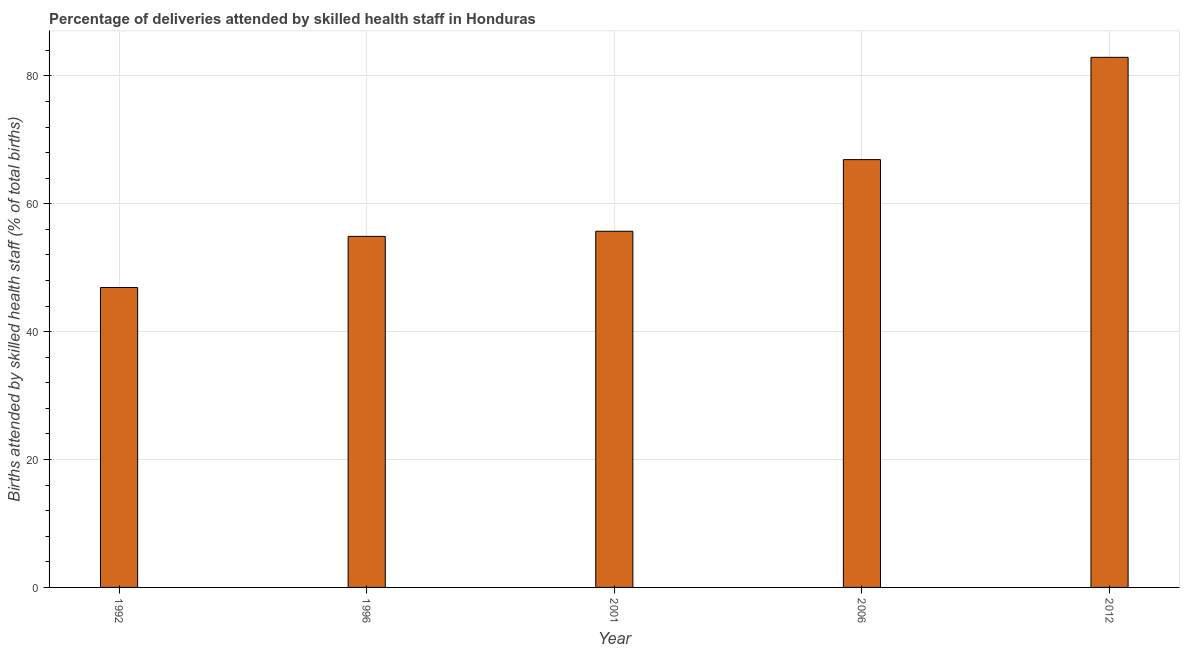What is the title of the graph?
Ensure brevity in your answer.  Percentage of deliveries attended by skilled health staff in Honduras. What is the label or title of the Y-axis?
Your answer should be very brief. Births attended by skilled health staff (% of total births). What is the number of births attended by skilled health staff in 2001?
Provide a succinct answer. 55.7. Across all years, what is the maximum number of births attended by skilled health staff?
Offer a terse response. 82.9. Across all years, what is the minimum number of births attended by skilled health staff?
Provide a succinct answer. 46.9. In which year was the number of births attended by skilled health staff maximum?
Offer a terse response. 2012. In which year was the number of births attended by skilled health staff minimum?
Give a very brief answer. 1992. What is the sum of the number of births attended by skilled health staff?
Make the answer very short. 307.3. What is the difference between the number of births attended by skilled health staff in 1992 and 2006?
Keep it short and to the point. -20. What is the average number of births attended by skilled health staff per year?
Provide a succinct answer. 61.46. What is the median number of births attended by skilled health staff?
Offer a very short reply. 55.7. In how many years, is the number of births attended by skilled health staff greater than 64 %?
Offer a terse response. 2. What is the ratio of the number of births attended by skilled health staff in 1996 to that in 2006?
Your response must be concise. 0.82. Is the difference between the number of births attended by skilled health staff in 1996 and 2006 greater than the difference between any two years?
Offer a very short reply. No. What is the difference between the highest and the second highest number of births attended by skilled health staff?
Keep it short and to the point. 16. What is the difference between the highest and the lowest number of births attended by skilled health staff?
Your answer should be very brief. 36. Are all the bars in the graph horizontal?
Your response must be concise. No. What is the Births attended by skilled health staff (% of total births) in 1992?
Your answer should be very brief. 46.9. What is the Births attended by skilled health staff (% of total births) in 1996?
Offer a terse response. 54.9. What is the Births attended by skilled health staff (% of total births) in 2001?
Offer a terse response. 55.7. What is the Births attended by skilled health staff (% of total births) of 2006?
Keep it short and to the point. 66.9. What is the Births attended by skilled health staff (% of total births) of 2012?
Your answer should be very brief. 82.9. What is the difference between the Births attended by skilled health staff (% of total births) in 1992 and 2001?
Provide a succinct answer. -8.8. What is the difference between the Births attended by skilled health staff (% of total births) in 1992 and 2006?
Provide a short and direct response. -20. What is the difference between the Births attended by skilled health staff (% of total births) in 1992 and 2012?
Make the answer very short. -36. What is the difference between the Births attended by skilled health staff (% of total births) in 1996 and 2012?
Give a very brief answer. -28. What is the difference between the Births attended by skilled health staff (% of total births) in 2001 and 2012?
Make the answer very short. -27.2. What is the difference between the Births attended by skilled health staff (% of total births) in 2006 and 2012?
Your response must be concise. -16. What is the ratio of the Births attended by skilled health staff (% of total births) in 1992 to that in 1996?
Give a very brief answer. 0.85. What is the ratio of the Births attended by skilled health staff (% of total births) in 1992 to that in 2001?
Keep it short and to the point. 0.84. What is the ratio of the Births attended by skilled health staff (% of total births) in 1992 to that in 2006?
Give a very brief answer. 0.7. What is the ratio of the Births attended by skilled health staff (% of total births) in 1992 to that in 2012?
Give a very brief answer. 0.57. What is the ratio of the Births attended by skilled health staff (% of total births) in 1996 to that in 2006?
Ensure brevity in your answer.  0.82. What is the ratio of the Births attended by skilled health staff (% of total births) in 1996 to that in 2012?
Provide a short and direct response. 0.66. What is the ratio of the Births attended by skilled health staff (% of total births) in 2001 to that in 2006?
Keep it short and to the point. 0.83. What is the ratio of the Births attended by skilled health staff (% of total births) in 2001 to that in 2012?
Make the answer very short. 0.67. What is the ratio of the Births attended by skilled health staff (% of total births) in 2006 to that in 2012?
Your response must be concise. 0.81. 